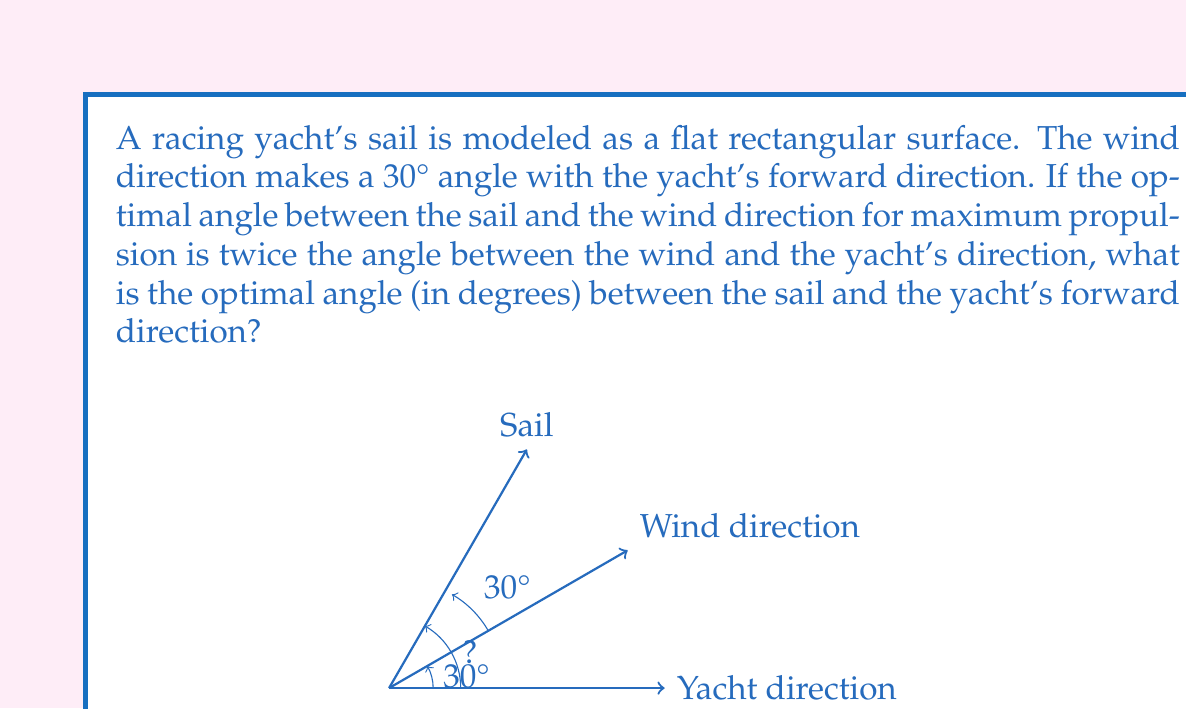Help me with this question. Let's approach this step-by-step:

1) Let $\theta$ be the angle between the wind direction and the yacht's forward direction. We're given that $\theta = 30°$.

2) The optimal angle between the sail and the wind direction is stated to be twice the angle between the wind and the yacht's direction. Let's call this optimal angle $\alpha$. So:

   $\alpha = 2\theta = 2(30°) = 60°$

3) We need to find the angle between the sail and the yacht's forward direction. Let's call this angle $\beta$.

4) We can see that $\beta$ is the sum of $\theta$ and $\alpha$:

   $\beta = \theta + \alpha$

5) Substituting the values we know:

   $\beta = 30° + 60° = 90°$

Therefore, the optimal angle between the sail and the yacht's forward direction is 90°.
Answer: 90° 